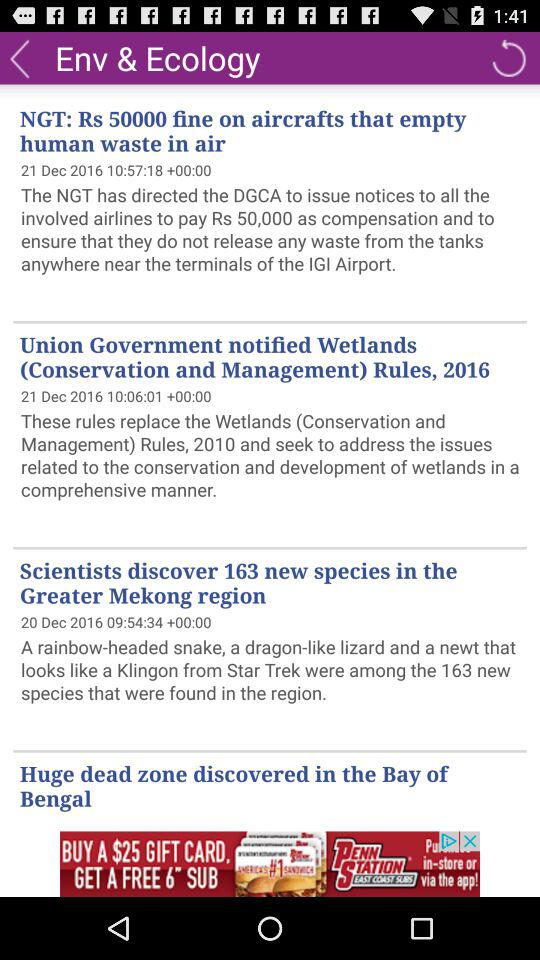When was "Huge dead zone discovered in the Bay of Bengal" published?
When the provided information is insufficient, respond with <no answer>. <no answer> 